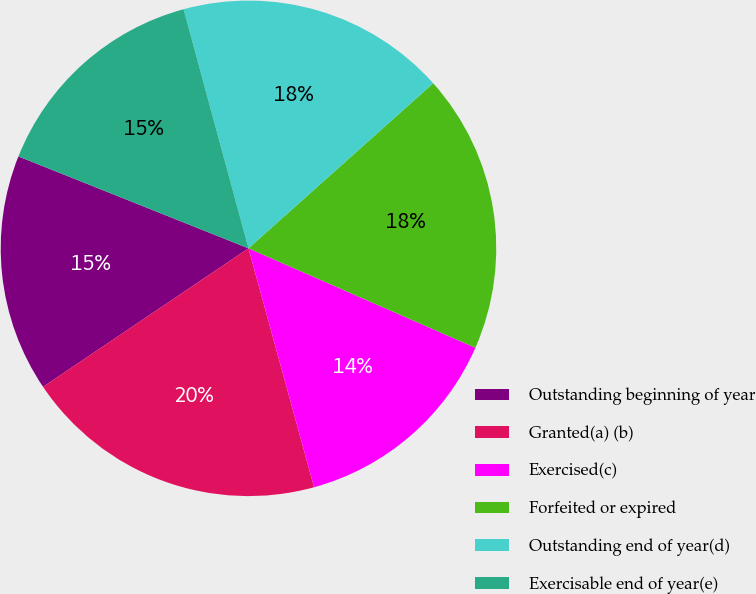Convert chart to OTSL. <chart><loc_0><loc_0><loc_500><loc_500><pie_chart><fcel>Outstanding beginning of year<fcel>Granted(a) (b)<fcel>Exercised(c)<fcel>Forfeited or expired<fcel>Outstanding end of year(d)<fcel>Exercisable end of year(e)<nl><fcel>15.49%<fcel>19.82%<fcel>14.16%<fcel>18.18%<fcel>17.61%<fcel>14.73%<nl></chart> 